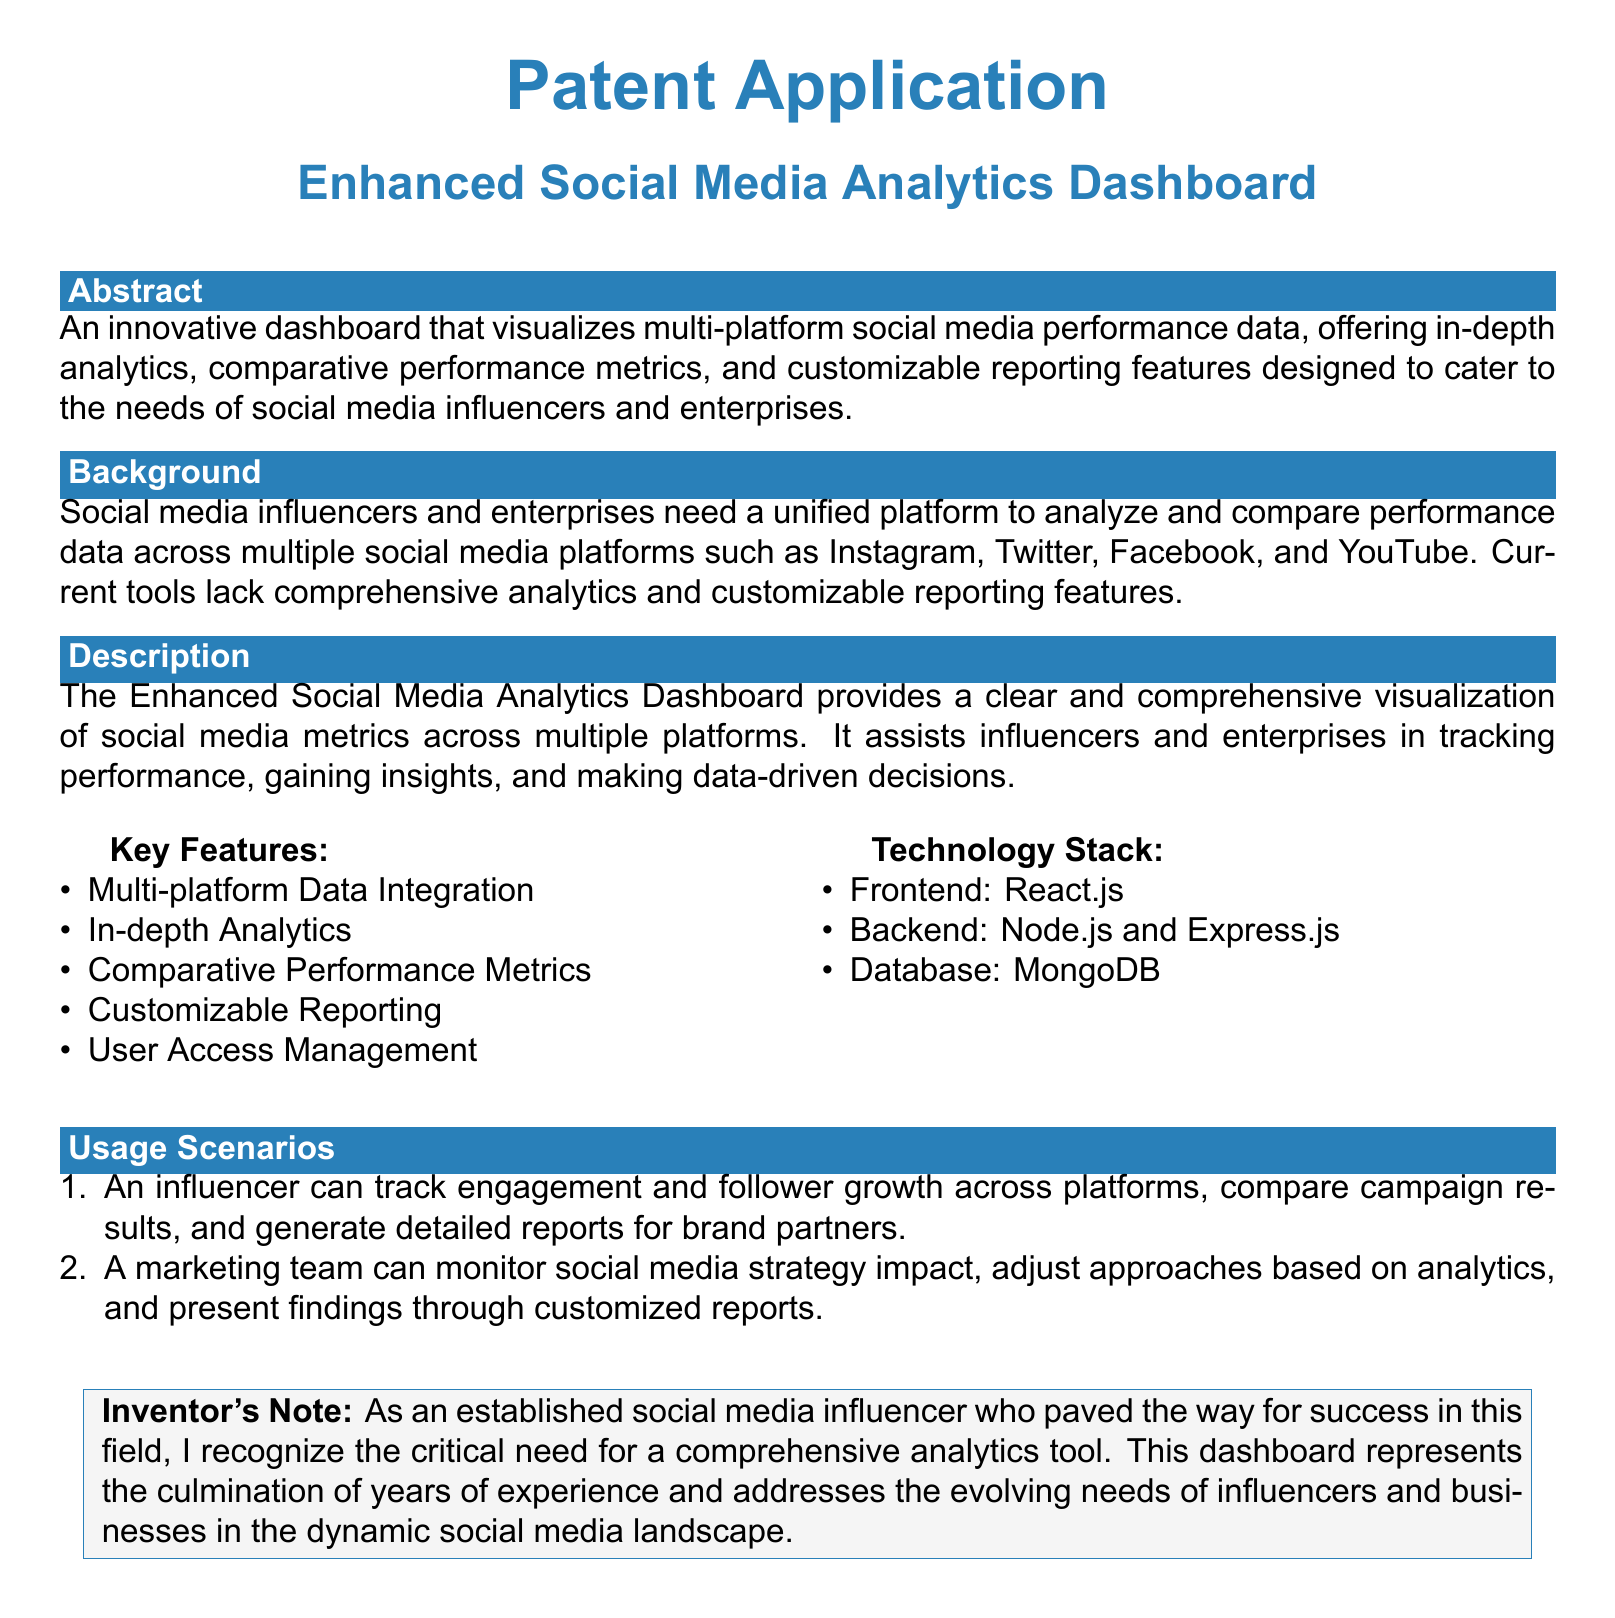What is the title of the patent application? The title provides the focus of the patent document, which is "Enhanced Social Media Analytics Dashboard."
Answer: Enhanced Social Media Analytics Dashboard What is one key feature of the dashboard? Key features are listed in the document, such as "Multi-platform Data Integration."
Answer: Multi-platform Data Integration What technology is used for the backend of the dashboard? The technology stack specifies the backend framework, which is mentioned in the document.
Answer: Node.js and Express.js What scenario involves an influencer tracking engagement? The usage scenarios outline specific examples, one of which involves tracking engagement.
Answer: An influencer can track engagement and follower growth across platforms How many platforms are mentioned for data integration in the background section? The background describes the number of platforms, which is four.
Answer: Four What kind of reports can users generate? The description refers to customizability in reporting features, explicitly stating the type of reports available.
Answer: Customizable Reporting Who recognizes the need for a comprehensive analytics tool? The inventor's note indicates who understands this critical need by stating "I recognize."
Answer: The established social media influencer What is the primary audience for the dashboard? The background section identifies the main user group for the analytics tool as specified.
Answer: Social media influencers and enterprises 